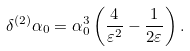Convert formula to latex. <formula><loc_0><loc_0><loc_500><loc_500>\delta ^ { ( 2 ) } \alpha _ { 0 } = \alpha _ { 0 } ^ { 3 } \left ( \frac { 4 } { \varepsilon ^ { 2 } } - \frac { 1 } { 2 \varepsilon } \right ) .</formula> 